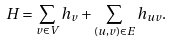Convert formula to latex. <formula><loc_0><loc_0><loc_500><loc_500>H = \sum _ { v \in V } h _ { v } + \sum _ { ( u , v ) \in E } h _ { u v } .</formula> 